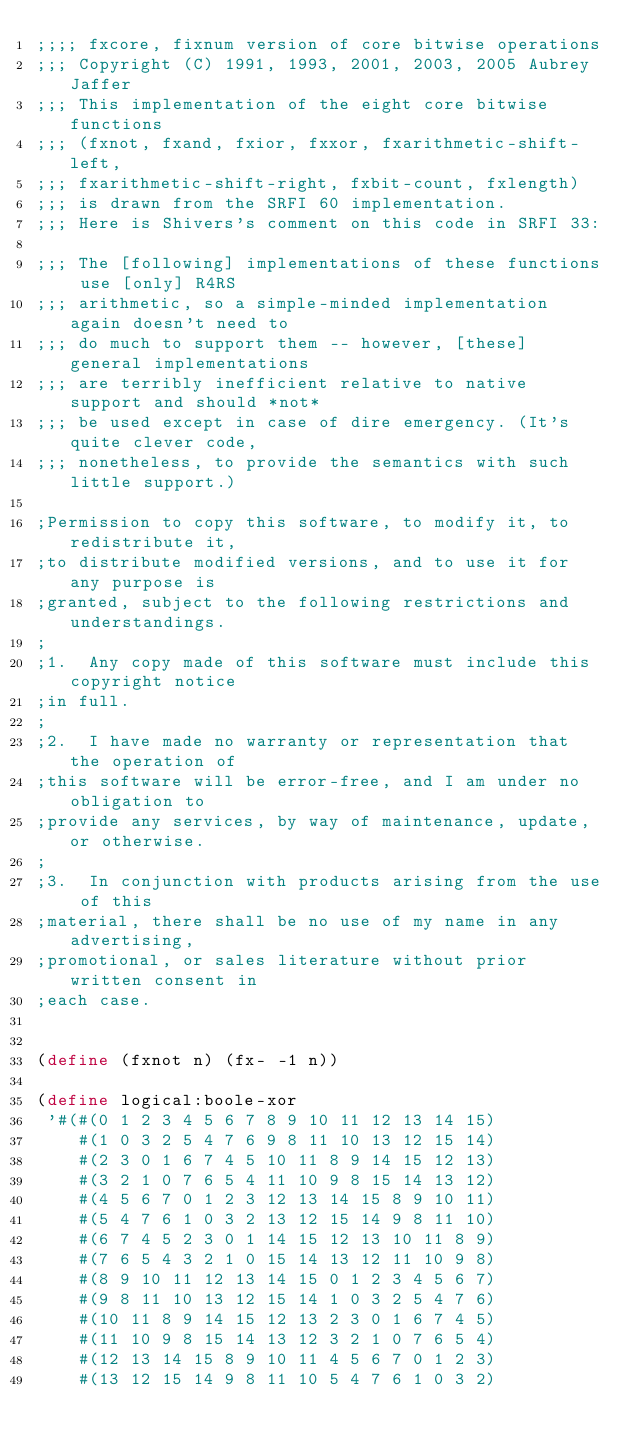<code> <loc_0><loc_0><loc_500><loc_500><_Scheme_>;;;; fxcore, fixnum version of core bitwise operations
;;; Copyright (C) 1991, 1993, 2001, 2003, 2005 Aubrey Jaffer
;;; This implementation of the eight core bitwise functions
;;; (fxnot, fxand, fxior, fxxor, fxarithmetic-shift-left,
;;; fxarithmetic-shift-right, fxbit-count, fxlength)
;;; is drawn from the SRFI 60 implementation.
;;; Here is Shivers's comment on this code in SRFI 33:

;;; The [following] implementations of these functions use [only] R4RS
;;; arithmetic, so a simple-minded implementation again doesn't need to
;;; do much to support them -- however, [these] general implementations
;;; are terribly inefficient relative to native support and should *not*
;;; be used except in case of dire emergency. (It's quite clever code,
;;; nonetheless, to provide the semantics with such little support.)

;Permission to copy this software, to modify it, to redistribute it,
;to distribute modified versions, and to use it for any purpose is
;granted, subject to the following restrictions and understandings.
;
;1.  Any copy made of this software must include this copyright notice
;in full.
;
;2.  I have made no warranty or representation that the operation of
;this software will be error-free, and I am under no obligation to
;provide any services, by way of maintenance, update, or otherwise.
;
;3.  In conjunction with products arising from the use of this
;material, there shall be no use of my name in any advertising,
;promotional, or sales literature without prior written consent in
;each case.


(define (fxnot n) (fx- -1 n))

(define logical:boole-xor
 '#(#(0 1 2 3 4 5 6 7 8 9 10 11 12 13 14 15)
    #(1 0 3 2 5 4 7 6 9 8 11 10 13 12 15 14)
    #(2 3 0 1 6 7 4 5 10 11 8 9 14 15 12 13)
    #(3 2 1 0 7 6 5 4 11 10 9 8 15 14 13 12)
    #(4 5 6 7 0 1 2 3 12 13 14 15 8 9 10 11)
    #(5 4 7 6 1 0 3 2 13 12 15 14 9 8 11 10)
    #(6 7 4 5 2 3 0 1 14 15 12 13 10 11 8 9)
    #(7 6 5 4 3 2 1 0 15 14 13 12 11 10 9 8)
    #(8 9 10 11 12 13 14 15 0 1 2 3 4 5 6 7)
    #(9 8 11 10 13 12 15 14 1 0 3 2 5 4 7 6)
    #(10 11 8 9 14 15 12 13 2 3 0 1 6 7 4 5)
    #(11 10 9 8 15 14 13 12 3 2 1 0 7 6 5 4)
    #(12 13 14 15 8 9 10 11 4 5 6 7 0 1 2 3)
    #(13 12 15 14 9 8 11 10 5 4 7 6 1 0 3 2)</code> 